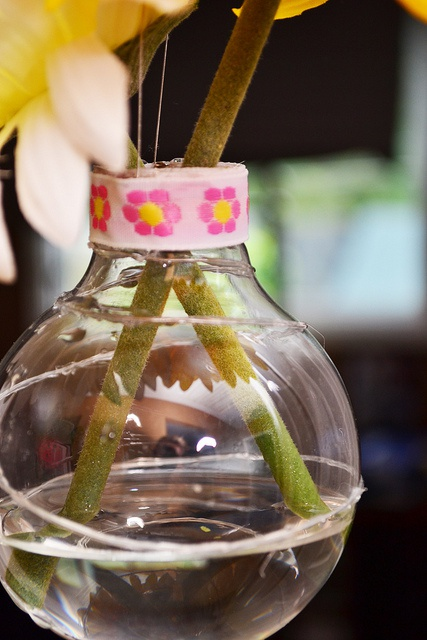Describe the objects in this image and their specific colors. I can see a vase in tan, gray, olive, and maroon tones in this image. 